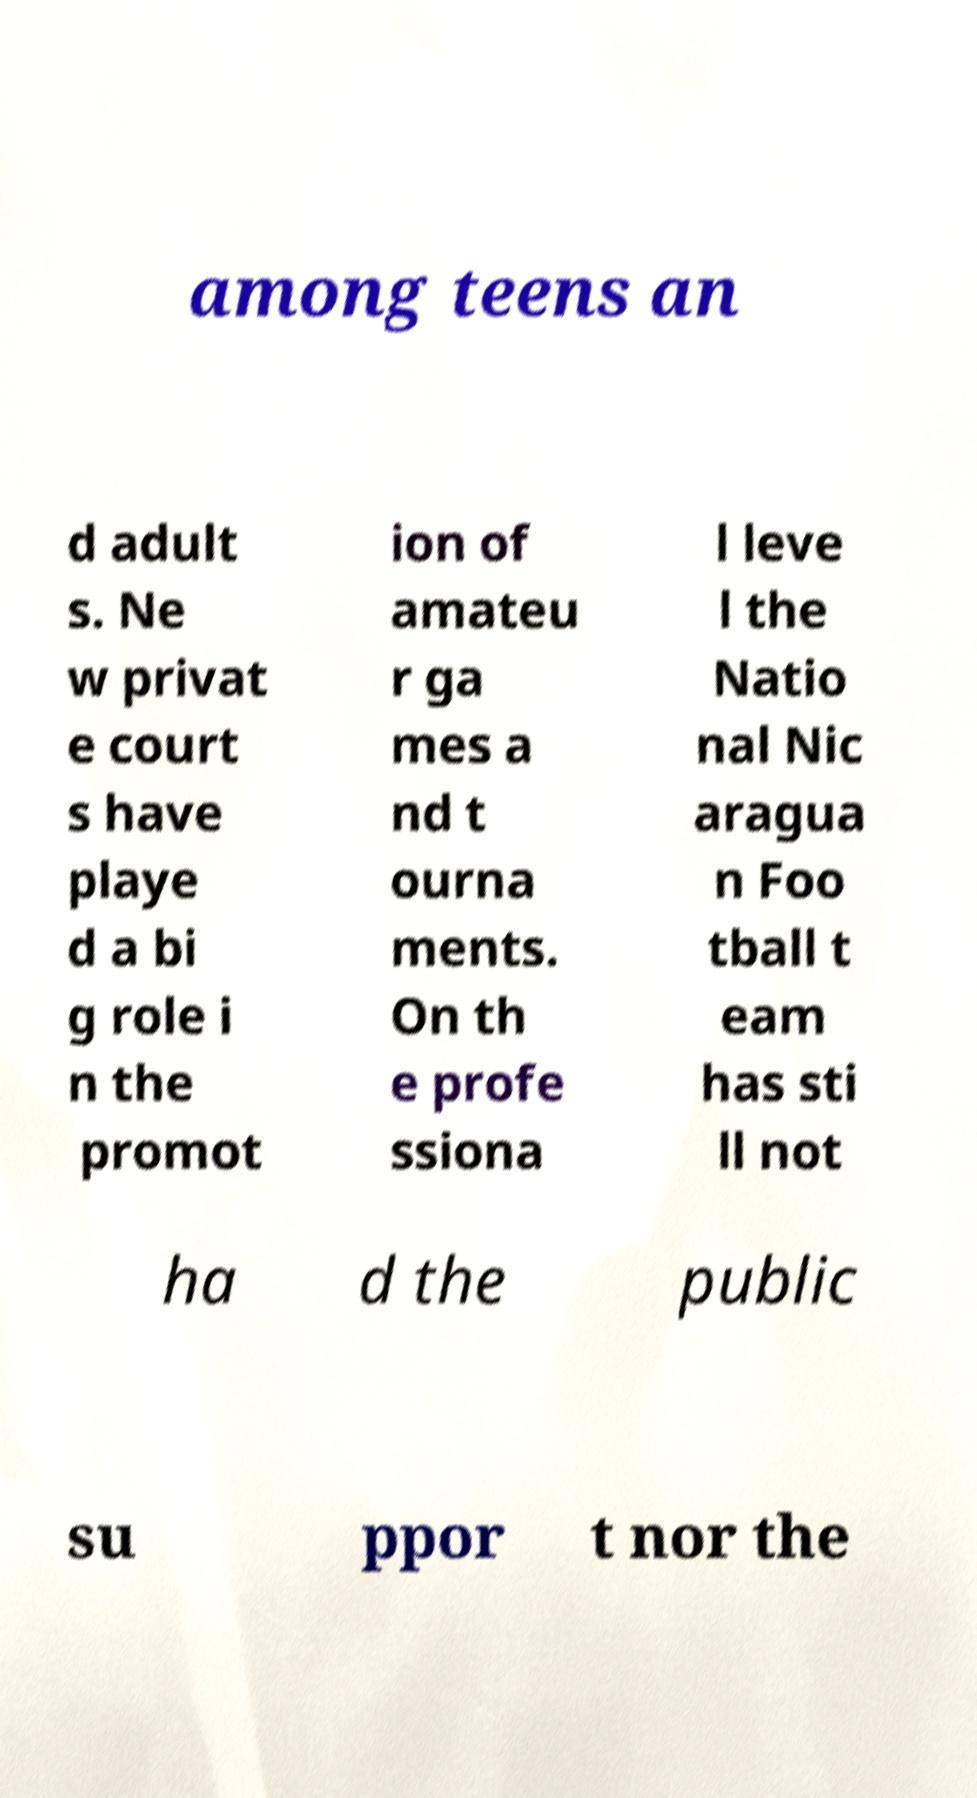Can you read and provide the text displayed in the image?This photo seems to have some interesting text. Can you extract and type it out for me? among teens an d adult s. Ne w privat e court s have playe d a bi g role i n the promot ion of amateu r ga mes a nd t ourna ments. On th e profe ssiona l leve l the Natio nal Nic aragua n Foo tball t eam has sti ll not ha d the public su ppor t nor the 